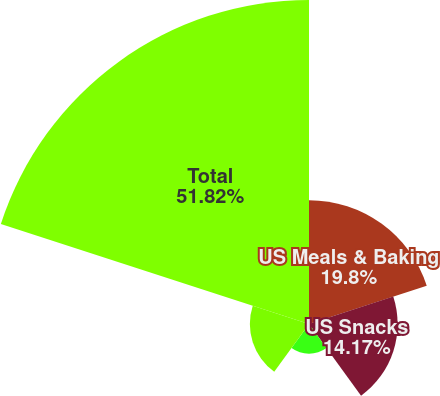Convert chart. <chart><loc_0><loc_0><loc_500><loc_500><pie_chart><fcel>US Meals & Baking<fcel>US Snacks<fcel>US Yogurt and Other<fcel>Canada (a)<fcel>Total<nl><fcel>19.8%<fcel>14.17%<fcel>4.75%<fcel>9.46%<fcel>51.82%<nl></chart> 